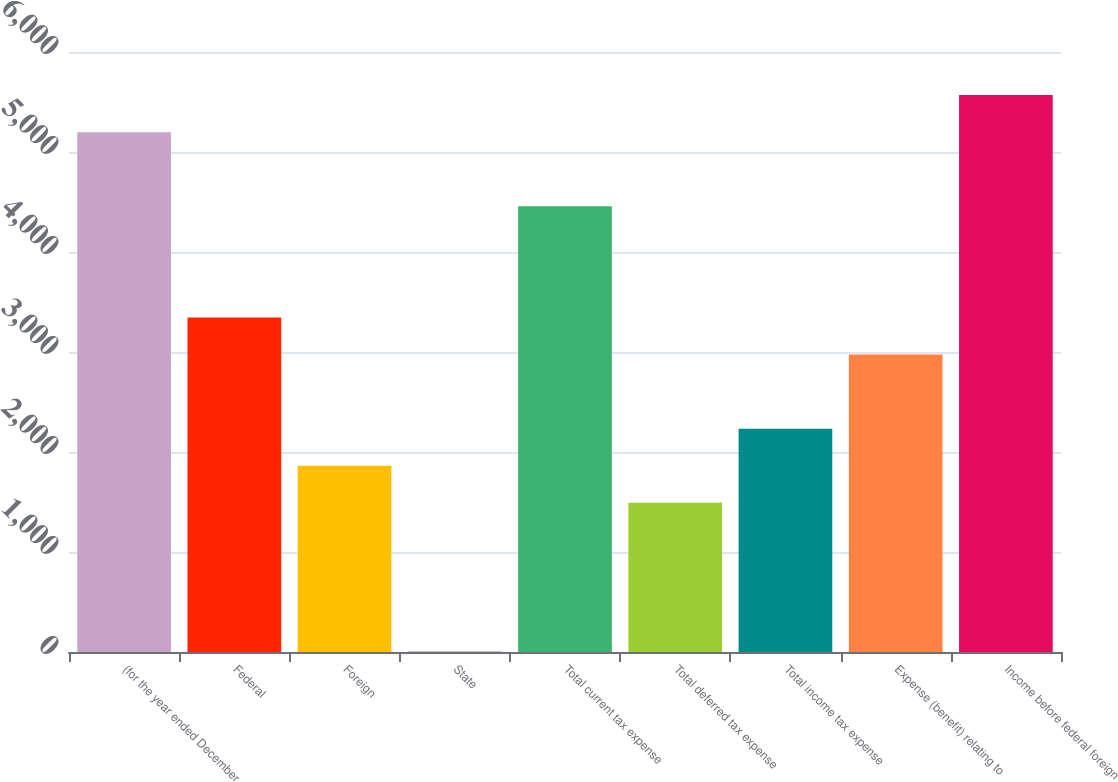Convert chart. <chart><loc_0><loc_0><loc_500><loc_500><bar_chart><fcel>(for the year ended December<fcel>Federal<fcel>Foreign<fcel>State<fcel>Total current tax expense<fcel>Total deferred tax expense<fcel>Total income tax expense<fcel>Expense (benefit) relating to<fcel>Income before federal foreign<nl><fcel>5198.4<fcel>3345.4<fcel>1863<fcel>10<fcel>4457.2<fcel>1492.4<fcel>2233.6<fcel>2974.8<fcel>5569<nl></chart> 